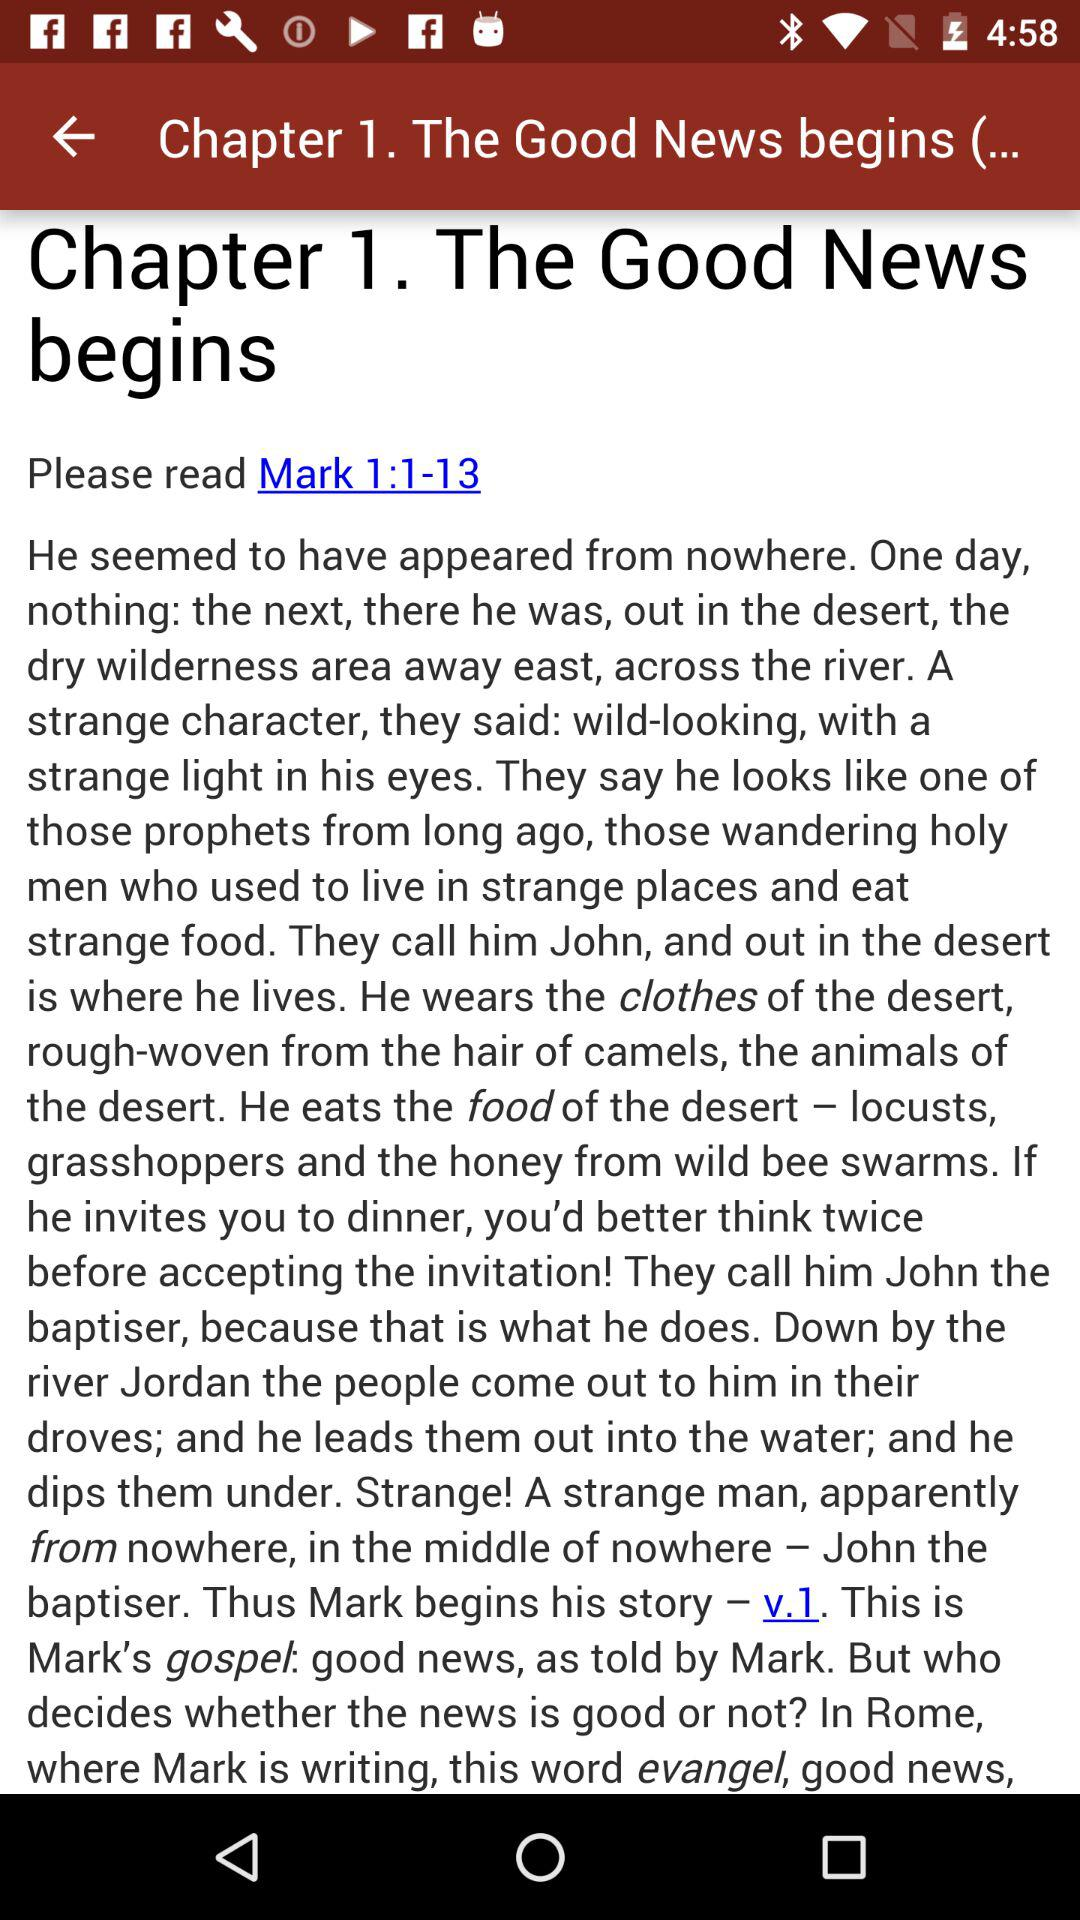Who is this application powered by?
When the provided information is insufficient, respond with <no answer>. <no answer> 